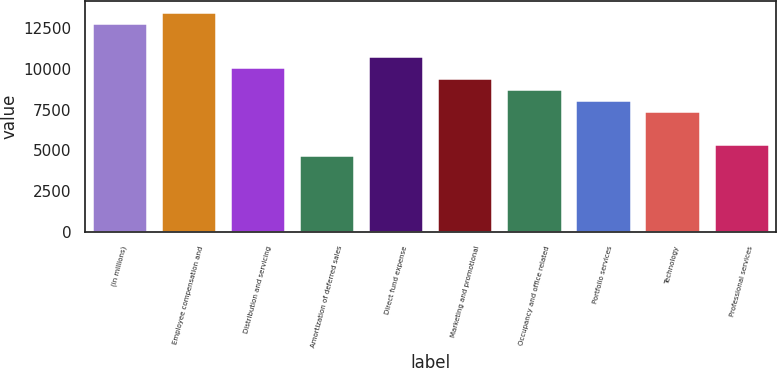Convert chart to OTSL. <chart><loc_0><loc_0><loc_500><loc_500><bar_chart><fcel>(in millions)<fcel>Employee compensation and<fcel>Distribution and servicing<fcel>Amortization of deferred sales<fcel>Direct fund expense<fcel>Marketing and promotional<fcel>Occupancy and office related<fcel>Portfolio services<fcel>Technology<fcel>Professional services<nl><fcel>12799.4<fcel>13473<fcel>10105<fcel>4716.2<fcel>10778.6<fcel>9431.4<fcel>8757.8<fcel>8084.2<fcel>7410.6<fcel>5389.8<nl></chart> 